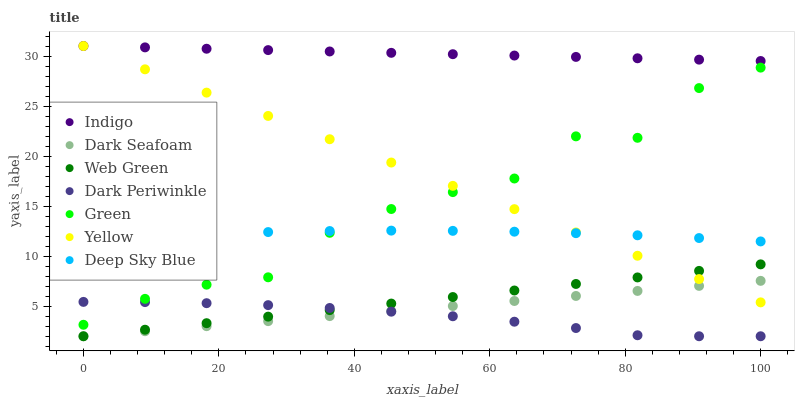Does Dark Periwinkle have the minimum area under the curve?
Answer yes or no. Yes. Does Indigo have the maximum area under the curve?
Answer yes or no. Yes. Does Yellow have the minimum area under the curve?
Answer yes or no. No. Does Yellow have the maximum area under the curve?
Answer yes or no. No. Is Web Green the smoothest?
Answer yes or no. Yes. Is Green the roughest?
Answer yes or no. Yes. Is Yellow the smoothest?
Answer yes or no. No. Is Yellow the roughest?
Answer yes or no. No. Does Dark Seafoam have the lowest value?
Answer yes or no. Yes. Does Yellow have the lowest value?
Answer yes or no. No. Does Yellow have the highest value?
Answer yes or no. Yes. Does Dark Seafoam have the highest value?
Answer yes or no. No. Is Dark Periwinkle less than Deep Sky Blue?
Answer yes or no. Yes. Is Indigo greater than Dark Periwinkle?
Answer yes or no. Yes. Does Dark Periwinkle intersect Green?
Answer yes or no. Yes. Is Dark Periwinkle less than Green?
Answer yes or no. No. Is Dark Periwinkle greater than Green?
Answer yes or no. No. Does Dark Periwinkle intersect Deep Sky Blue?
Answer yes or no. No. 